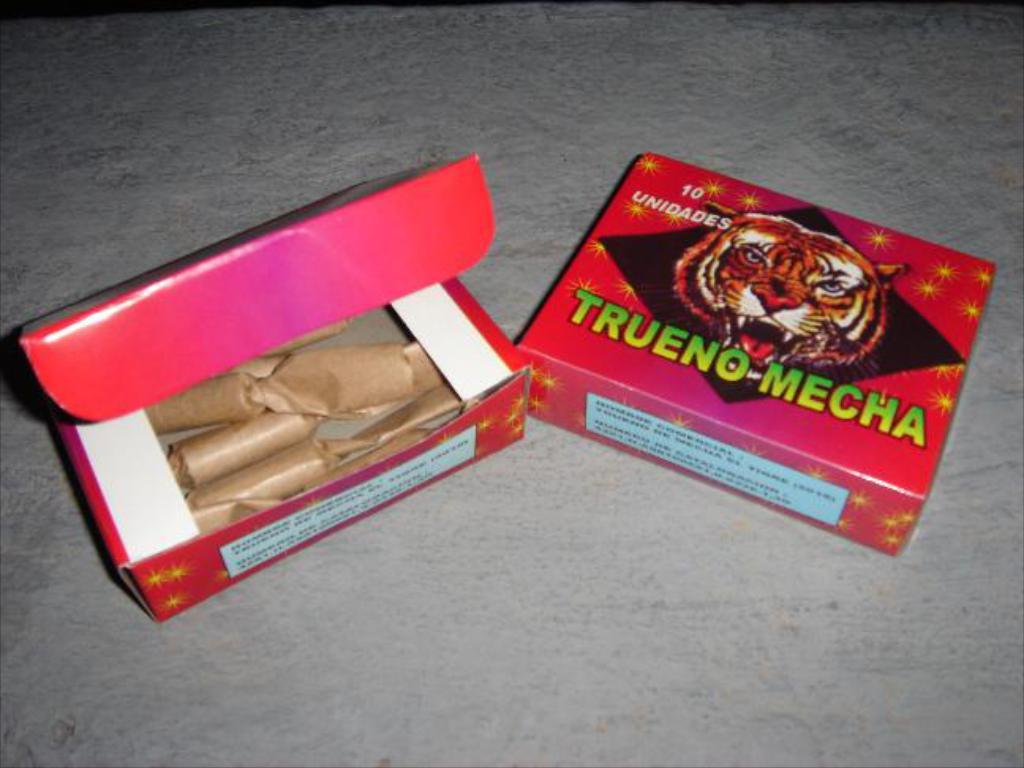<image>
Present a compact description of the photo's key features. A box of Trueno Mecha has a tiger on it. 